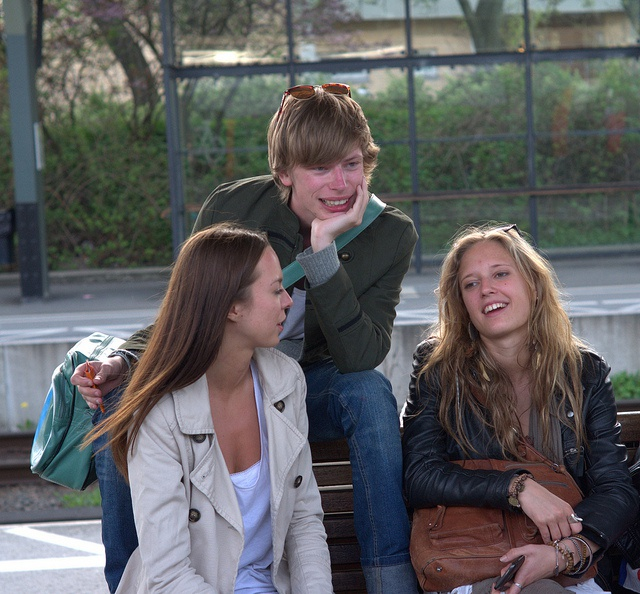Describe the objects in this image and their specific colors. I can see people in tan, darkgray, black, and gray tones, people in tan, black, navy, gray, and blue tones, people in tan, black, gray, and maroon tones, handbag in tan, maroon, black, and brown tones, and handbag in tan, teal, white, and black tones in this image. 